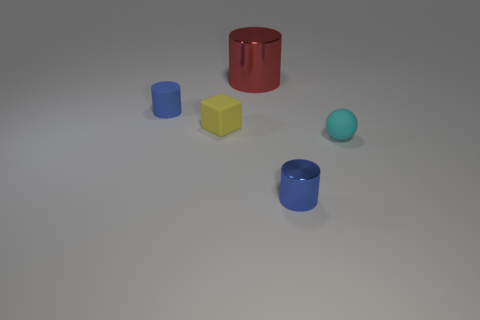Subtract all small cylinders. How many cylinders are left? 1 Add 3 big metallic cylinders. How many objects exist? 8 Subtract all blocks. How many objects are left? 4 Add 3 metallic things. How many metallic things are left? 5 Add 2 small blue rubber objects. How many small blue rubber objects exist? 3 Subtract all red cylinders. How many cylinders are left? 2 Subtract 0 green cubes. How many objects are left? 5 Subtract all blue blocks. Subtract all gray cylinders. How many blocks are left? 1 Subtract all gray cubes. How many blue cylinders are left? 2 Subtract all big cyan metallic objects. Subtract all big red metal cylinders. How many objects are left? 4 